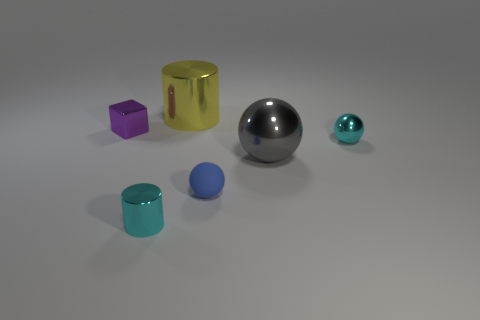Add 1 small matte spheres. How many objects exist? 7 Subtract all blocks. How many objects are left? 5 Subtract 0 red spheres. How many objects are left? 6 Subtract all small cylinders. Subtract all cubes. How many objects are left? 4 Add 2 small blue rubber things. How many small blue rubber things are left? 3 Add 1 red shiny blocks. How many red shiny blocks exist? 1 